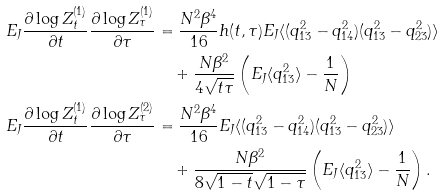<formula> <loc_0><loc_0><loc_500><loc_500>E _ { J } \frac { \partial \log Z _ { t } ^ { ( 1 ) } } { \partial t } \frac { \partial \log Z _ { \tau } ^ { ( 1 ) } } { \partial \tau } & = \frac { N ^ { 2 } \beta ^ { 4 } } { 1 6 } h ( t , \tau ) E _ { J } \langle ( q _ { 1 3 } ^ { 2 } - q _ { 1 4 } ^ { 2 } ) ( q _ { 1 3 } ^ { 2 } - q _ { 2 3 } ^ { 2 } ) \rangle \\ & \quad + \frac { N \beta ^ { 2 } } { 4 \sqrt { t \tau } } \left ( E _ { J } \langle q _ { 1 3 } ^ { 2 } \rangle - \frac { 1 } { N } \right ) \\ E _ { J } \frac { \partial \log Z _ { t } ^ { ( 1 ) } } { \partial t } \frac { \partial \log Z _ { \tau } ^ { ( 2 ) } } { \partial \tau } & = \frac { N ^ { 2 } \beta ^ { 4 } } { 1 6 } E _ { J } \langle ( q _ { 1 3 } ^ { 2 } - q _ { 1 4 } ^ { 2 } ) ( q _ { 1 3 } ^ { 2 } - q _ { 2 3 } ^ { 2 } ) \rangle \\ & \quad + \frac { N \beta ^ { 2 } } { 8 \sqrt { 1 - t } \sqrt { 1 - \tau } } \left ( E _ { J } \langle q _ { 1 3 } ^ { 2 } \rangle - \frac { 1 } { N } \right ) .</formula> 